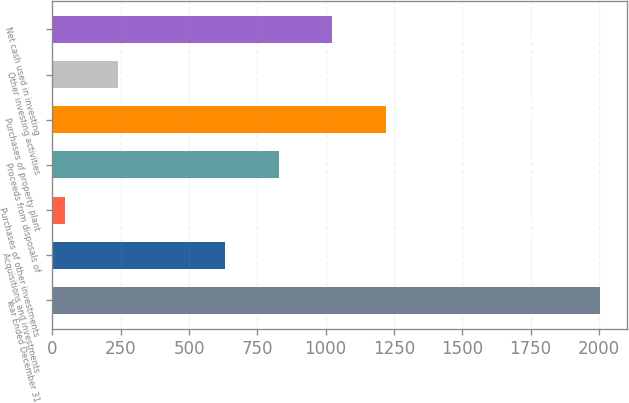Convert chart to OTSL. <chart><loc_0><loc_0><loc_500><loc_500><bar_chart><fcel>Year Ended December 31<fcel>Acquisitions and investments<fcel>Purchases of other investments<fcel>Proceeds from disposals of<fcel>Purchases of property plant<fcel>Other investing activities<fcel>Net cash used in investing<nl><fcel>2004<fcel>633.4<fcel>46<fcel>829.2<fcel>1220.8<fcel>241.8<fcel>1025<nl></chart> 